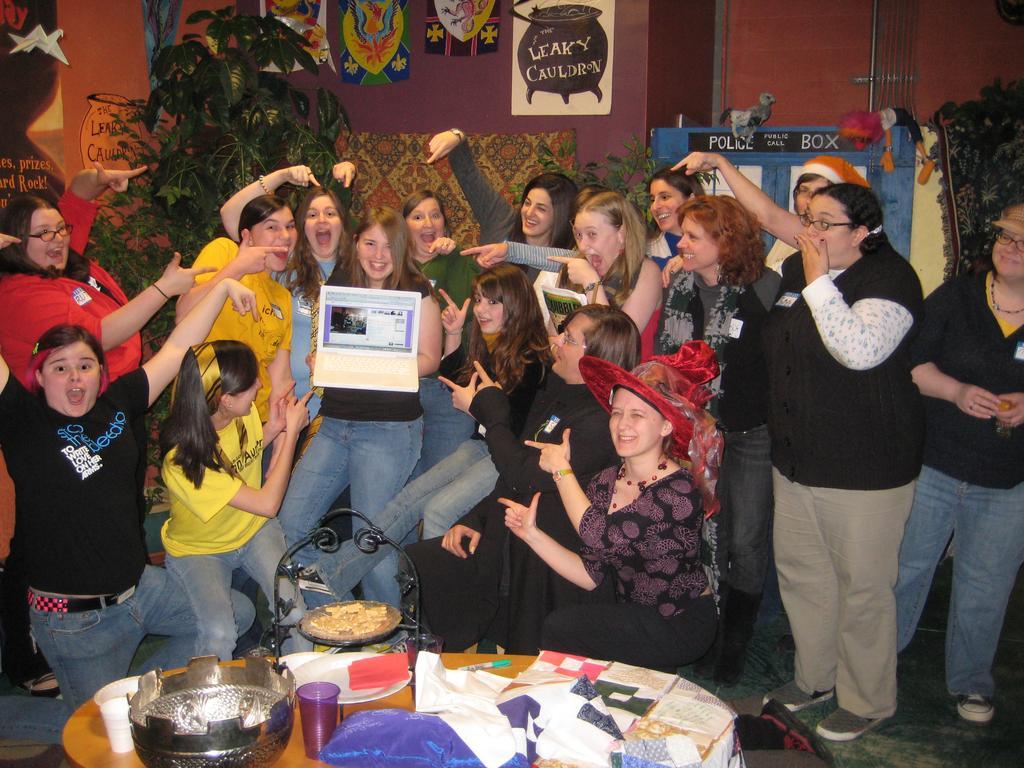Describe this image in one or two sentences. There are many people. One lady is wearing a hat. Another lady is holding something in the hand. In front of them there is a table. On that there is a glass, plate and many other items. In the back there are plants. Also there is a wall with paintings and many other things. 